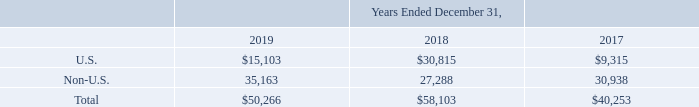NOTES TO CONSOLIDATED FINANCIAL STATEMENTS (in thousands, except for share and per share data)
NOTE 18 — Income Taxes
Earnings before income taxes consist of the following:
Which years does the table provide information for Earnings before income taxes? 2019, 2018, 2017. What was the total earnings in 2019?
Answer scale should be: thousand. 50,266. What was the amount of earnings from Non-U.S. sources in 2017?
Answer scale should be: thousand. 30,938. Which years did earnings from Non-U.S. sources exceed $30,000 thousand? (2019:35,163),(2017:30,938)
Answer: 2019, 2017. What was the change in the earnings from U.S. between 2017 and 2018?
Answer scale should be: thousand. 30,815-9,315
Answer: 21500. What was the percentage change in the total earnings between 2018 and 2019?
Answer scale should be: percent. (50,266-58,103)/58,103
Answer: -13.49. 